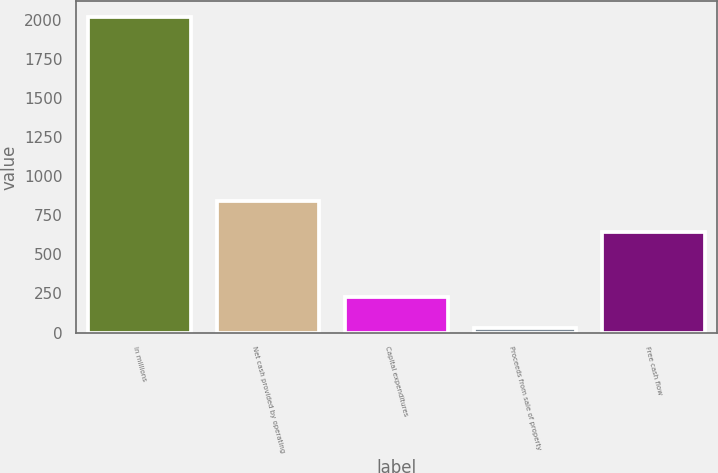Convert chart. <chart><loc_0><loc_0><loc_500><loc_500><bar_chart><fcel>In millions<fcel>Net cash provided by operating<fcel>Capital expenditures<fcel>Proceeds from sale of property<fcel>Free cash flow<nl><fcel>2015<fcel>841.77<fcel>226.07<fcel>27.3<fcel>643<nl></chart> 